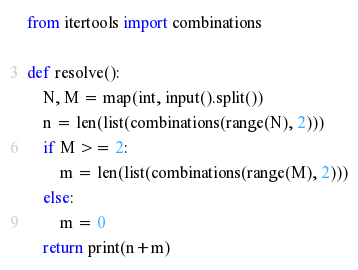Convert code to text. <code><loc_0><loc_0><loc_500><loc_500><_Python_>from itertools import combinations

def resolve():
    N, M = map(int, input().split())
    n = len(list(combinations(range(N), 2)))
    if M >= 2:
        m = len(list(combinations(range(M), 2)))
    else:
        m = 0
    return print(n+m)</code> 